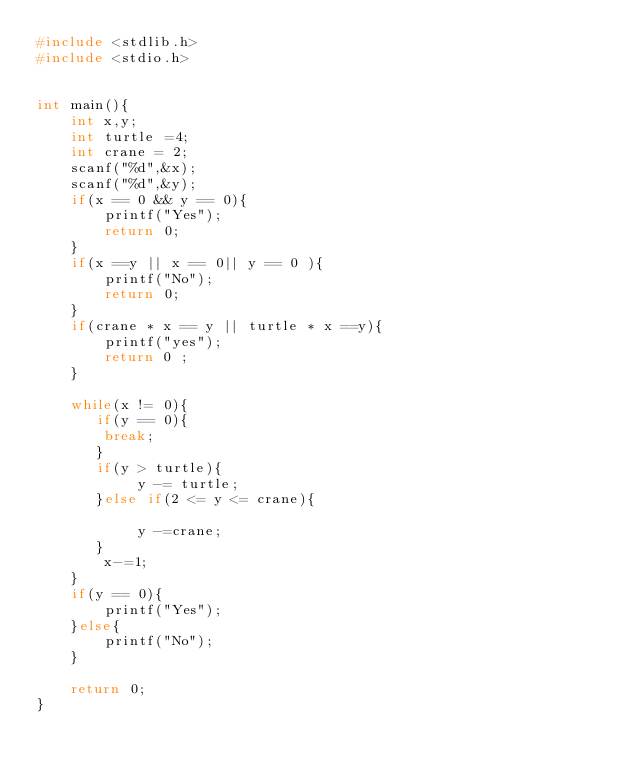Convert code to text. <code><loc_0><loc_0><loc_500><loc_500><_C_>#include <stdlib.h>
#include <stdio.h>


int main(){
    int x,y;
    int turtle =4;
    int crane = 2;
    scanf("%d",&x);
    scanf("%d",&y);
    if(x == 0 && y == 0){
        printf("Yes");
        return 0;
    } 
    if(x ==y || x == 0|| y == 0 ){
        printf("No");
        return 0;
    }
    if(crane * x == y || turtle * x ==y){
        printf("yes");
        return 0 ;
    }
    
    while(x != 0){
       if(y == 0){
        break;
       } 
       if(y > turtle){
            y -= turtle;
       }else if(2 <= y <= crane){

            y -=crane;
       } 
        x-=1;
    }    
    if(y == 0){
        printf("Yes");
    }else{
        printf("No");
    }

    return 0;
}
</code> 